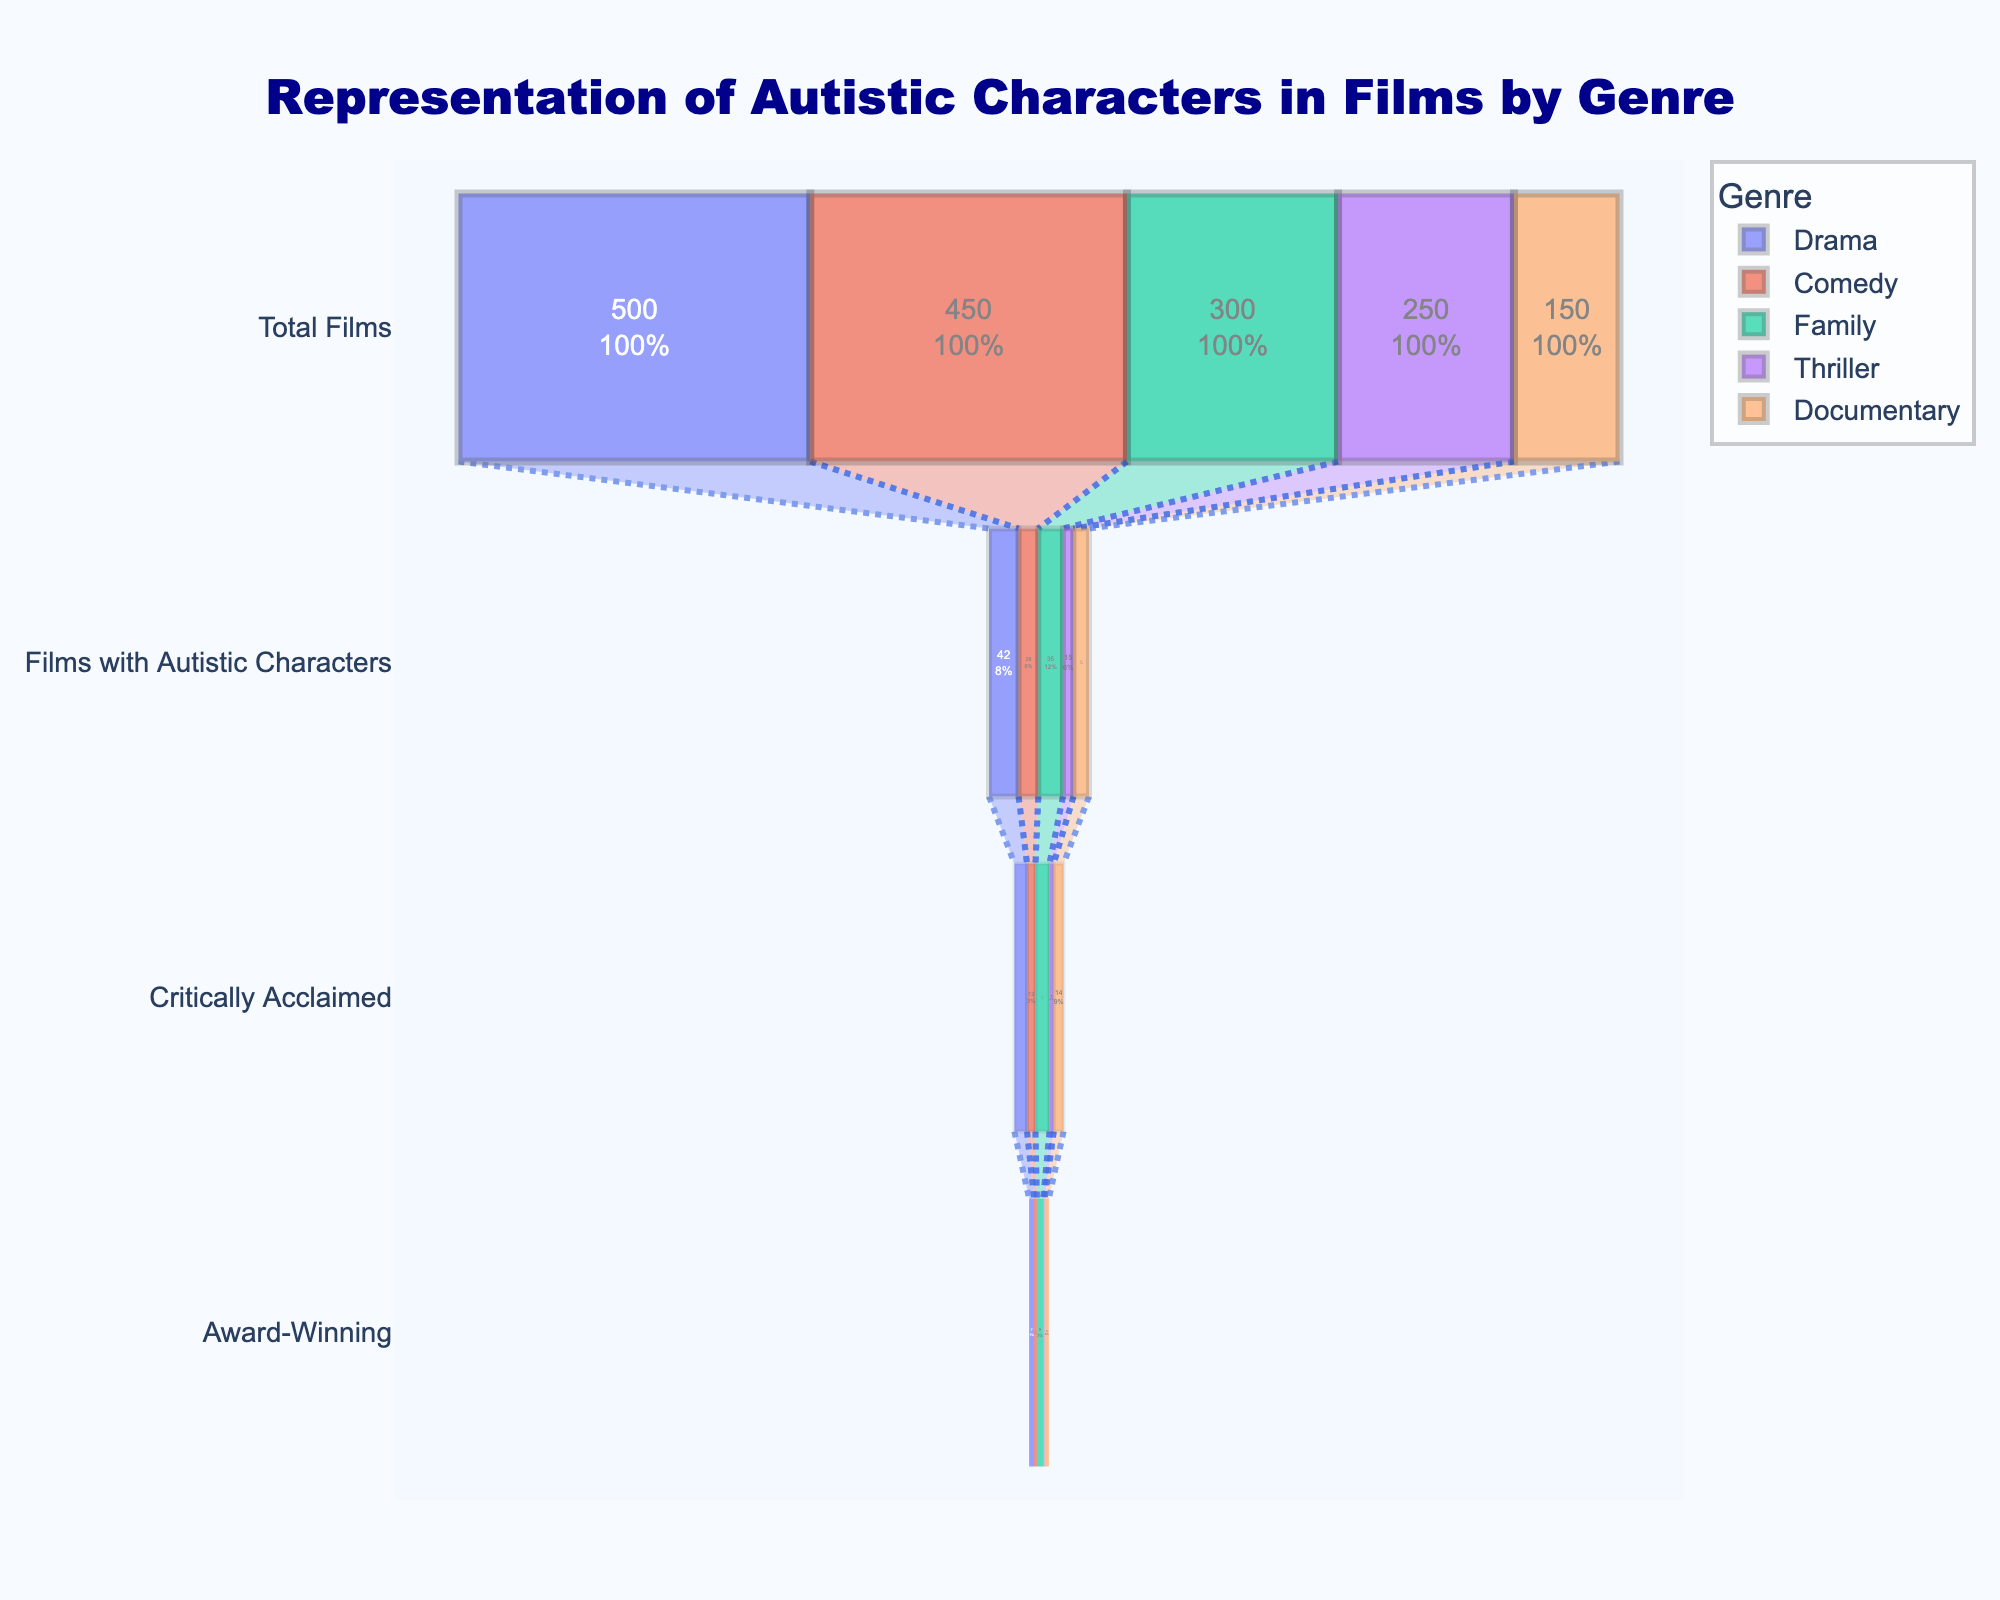What is the title of the figure? The title of the figure is typically displayed at the top. In this case, it reads "Representation of Autistic Characters in Films by Genre."
Answer: Representation of Autistic Characters in Films by Genre Which genre has the most films with autistic characters? By comparing the "Films with Autistic Characters" section of each funnel, Family films have the highest number with 35 films.
Answer: Family How many documentaries with autistic characters are award-winning? Looking at the "Award-Winning" stage within the Documentary funnel, it shows 6 films.
Answer: 6 What percentage of comedies with autistic characters are critically acclaimed? Refer to the Comedy funnel's "Critically Acclaimed" section compared to the "Films with Autistic Characters" section. The calculation is (12/28) * 100%.
Answer: ~42.86% Which genre has the highest conversion rate from "Films with Autistic Characters" to "Critically Acclaimed"? Calculate the conversion rate for each genre by dividing the number of critically acclaimed films by the number of films with autistic characters and comparing them. Documentary has the highest conversion rate with 14/22 ≈ 63.64%.
Answer: Documentary How do the number of critically acclaimed films in the Drama genre compare to those in the Thriller genre? Compare the "Critically Acclaimed" stage numbers between Drama and Thriller genres. Drama has 18 while Thriller has 6, making Drama significantly higher.
Answer: Drama What percentage of total films in the "Family" genre feature autistic characters? Calculate the percentage by dividing the number of Films with Autistic Characters by the Total Films in the Family genre: (35/300) * 100%.
Answer: ~11.67% Which genre has the smallest number of films featuring autistic characters? Compare the "Films with Autistic Characters" sections across all genres. Thriller has the smallest number, with 15 films.
Answer: Thriller How does the total number of Drama films compare to the total number of Family films? Compare the "Total Films" section for Drama and Family. Drama has 500 films, while Family has 300 films, so Drama has more total films.
Answer: Drama has more What is the relationship between the number of critically acclaimed films and award-winning films in each genre? Observe the numbers in the "Critically Acclaimed" and "Award-Winning" sections of each funnel. Generally, not all critically acclaimed films win awards, as shown by always having smaller numbers in the award-winning stage.
Answer: Award-winning films are fewer than critically acclaimed in all genres 